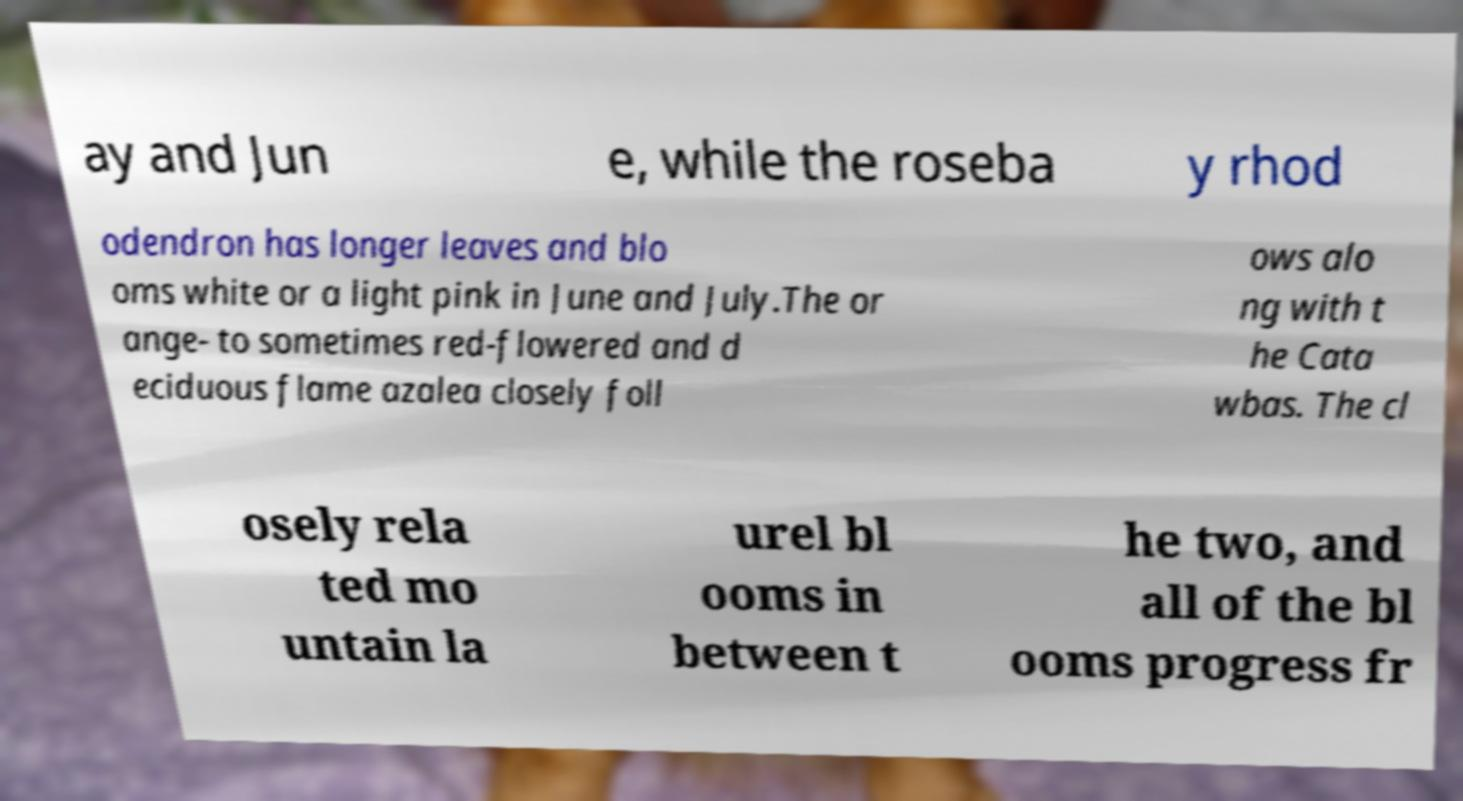Could you extract and type out the text from this image? ay and Jun e, while the roseba y rhod odendron has longer leaves and blo oms white or a light pink in June and July.The or ange- to sometimes red-flowered and d eciduous flame azalea closely foll ows alo ng with t he Cata wbas. The cl osely rela ted mo untain la urel bl ooms in between t he two, and all of the bl ooms progress fr 